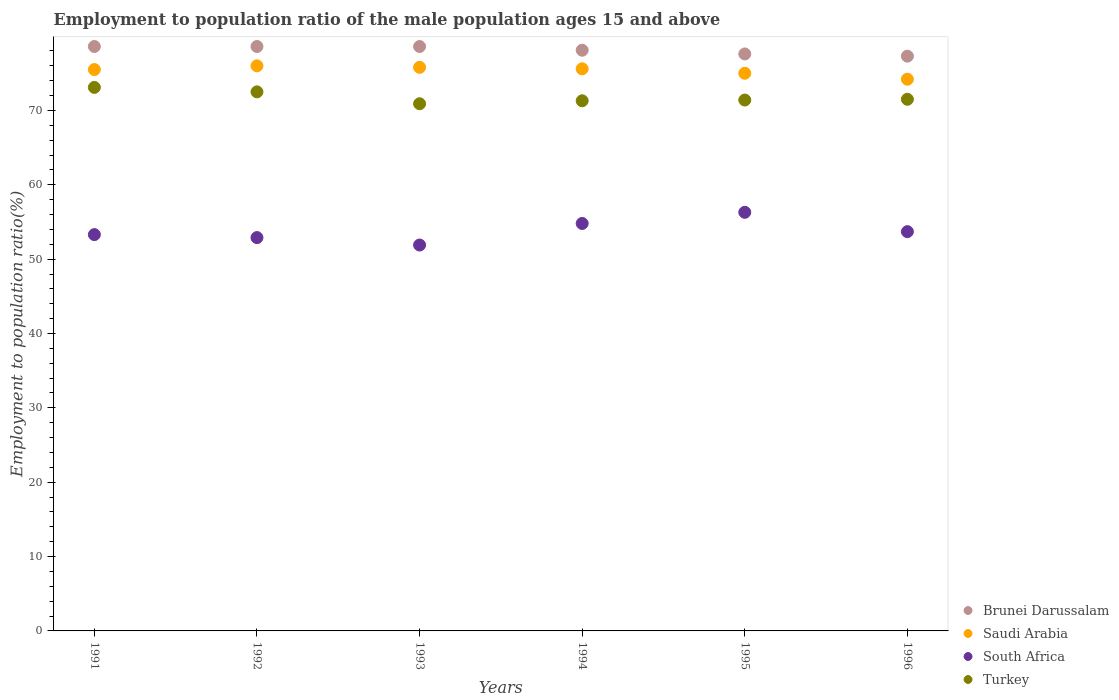Is the number of dotlines equal to the number of legend labels?
Offer a very short reply. Yes. What is the employment to population ratio in South Africa in 1995?
Offer a very short reply. 56.3. Across all years, what is the maximum employment to population ratio in South Africa?
Your answer should be compact. 56.3. Across all years, what is the minimum employment to population ratio in Brunei Darussalam?
Your response must be concise. 77.3. In which year was the employment to population ratio in Brunei Darussalam maximum?
Offer a very short reply. 1991. In which year was the employment to population ratio in South Africa minimum?
Ensure brevity in your answer.  1993. What is the total employment to population ratio in Turkey in the graph?
Give a very brief answer. 430.7. What is the difference between the employment to population ratio in Turkey in 1992 and that in 1994?
Offer a terse response. 1.2. What is the difference between the employment to population ratio in Turkey in 1992 and the employment to population ratio in Brunei Darussalam in 1995?
Provide a short and direct response. -5.1. What is the average employment to population ratio in Saudi Arabia per year?
Provide a short and direct response. 75.35. In the year 1991, what is the difference between the employment to population ratio in Saudi Arabia and employment to population ratio in South Africa?
Ensure brevity in your answer.  22.2. What is the ratio of the employment to population ratio in South Africa in 1991 to that in 1995?
Offer a very short reply. 0.95. Is the employment to population ratio in Turkey in 1992 less than that in 1994?
Your answer should be compact. No. What is the difference between the highest and the second highest employment to population ratio in Turkey?
Your answer should be compact. 0.6. What is the difference between the highest and the lowest employment to population ratio in Saudi Arabia?
Keep it short and to the point. 1.8. In how many years, is the employment to population ratio in South Africa greater than the average employment to population ratio in South Africa taken over all years?
Provide a short and direct response. 2. Is the sum of the employment to population ratio in Turkey in 1992 and 1994 greater than the maximum employment to population ratio in Brunei Darussalam across all years?
Ensure brevity in your answer.  Yes. Does the employment to population ratio in Brunei Darussalam monotonically increase over the years?
Ensure brevity in your answer.  No. Is the employment to population ratio in South Africa strictly less than the employment to population ratio in Saudi Arabia over the years?
Your response must be concise. Yes. How many dotlines are there?
Keep it short and to the point. 4. How many years are there in the graph?
Ensure brevity in your answer.  6. What is the difference between two consecutive major ticks on the Y-axis?
Your answer should be compact. 10. Does the graph contain any zero values?
Give a very brief answer. No. What is the title of the graph?
Keep it short and to the point. Employment to population ratio of the male population ages 15 and above. Does "Trinidad and Tobago" appear as one of the legend labels in the graph?
Provide a succinct answer. No. What is the label or title of the Y-axis?
Offer a terse response. Employment to population ratio(%). What is the Employment to population ratio(%) in Brunei Darussalam in 1991?
Your response must be concise. 78.6. What is the Employment to population ratio(%) of Saudi Arabia in 1991?
Your response must be concise. 75.5. What is the Employment to population ratio(%) in South Africa in 1991?
Keep it short and to the point. 53.3. What is the Employment to population ratio(%) in Turkey in 1991?
Keep it short and to the point. 73.1. What is the Employment to population ratio(%) in Brunei Darussalam in 1992?
Provide a succinct answer. 78.6. What is the Employment to population ratio(%) in South Africa in 1992?
Give a very brief answer. 52.9. What is the Employment to population ratio(%) of Turkey in 1992?
Give a very brief answer. 72.5. What is the Employment to population ratio(%) in Brunei Darussalam in 1993?
Keep it short and to the point. 78.6. What is the Employment to population ratio(%) in Saudi Arabia in 1993?
Keep it short and to the point. 75.8. What is the Employment to population ratio(%) of South Africa in 1993?
Offer a terse response. 51.9. What is the Employment to population ratio(%) of Turkey in 1993?
Make the answer very short. 70.9. What is the Employment to population ratio(%) of Brunei Darussalam in 1994?
Provide a succinct answer. 78.1. What is the Employment to population ratio(%) in Saudi Arabia in 1994?
Offer a very short reply. 75.6. What is the Employment to population ratio(%) in South Africa in 1994?
Give a very brief answer. 54.8. What is the Employment to population ratio(%) of Turkey in 1994?
Your answer should be compact. 71.3. What is the Employment to population ratio(%) of Brunei Darussalam in 1995?
Your response must be concise. 77.6. What is the Employment to population ratio(%) of Saudi Arabia in 1995?
Offer a terse response. 75. What is the Employment to population ratio(%) in South Africa in 1995?
Your response must be concise. 56.3. What is the Employment to population ratio(%) of Turkey in 1995?
Provide a succinct answer. 71.4. What is the Employment to population ratio(%) in Brunei Darussalam in 1996?
Your answer should be very brief. 77.3. What is the Employment to population ratio(%) of Saudi Arabia in 1996?
Offer a terse response. 74.2. What is the Employment to population ratio(%) of South Africa in 1996?
Keep it short and to the point. 53.7. What is the Employment to population ratio(%) in Turkey in 1996?
Give a very brief answer. 71.5. Across all years, what is the maximum Employment to population ratio(%) in Brunei Darussalam?
Provide a succinct answer. 78.6. Across all years, what is the maximum Employment to population ratio(%) in Saudi Arabia?
Ensure brevity in your answer.  76. Across all years, what is the maximum Employment to population ratio(%) in South Africa?
Make the answer very short. 56.3. Across all years, what is the maximum Employment to population ratio(%) of Turkey?
Make the answer very short. 73.1. Across all years, what is the minimum Employment to population ratio(%) in Brunei Darussalam?
Make the answer very short. 77.3. Across all years, what is the minimum Employment to population ratio(%) in Saudi Arabia?
Provide a short and direct response. 74.2. Across all years, what is the minimum Employment to population ratio(%) of South Africa?
Ensure brevity in your answer.  51.9. Across all years, what is the minimum Employment to population ratio(%) of Turkey?
Ensure brevity in your answer.  70.9. What is the total Employment to population ratio(%) of Brunei Darussalam in the graph?
Give a very brief answer. 468.8. What is the total Employment to population ratio(%) of Saudi Arabia in the graph?
Offer a terse response. 452.1. What is the total Employment to population ratio(%) of South Africa in the graph?
Provide a succinct answer. 322.9. What is the total Employment to population ratio(%) of Turkey in the graph?
Make the answer very short. 430.7. What is the difference between the Employment to population ratio(%) in Brunei Darussalam in 1991 and that in 1992?
Provide a succinct answer. 0. What is the difference between the Employment to population ratio(%) in South Africa in 1991 and that in 1992?
Ensure brevity in your answer.  0.4. What is the difference between the Employment to population ratio(%) of Brunei Darussalam in 1991 and that in 1993?
Your response must be concise. 0. What is the difference between the Employment to population ratio(%) in Saudi Arabia in 1991 and that in 1993?
Your answer should be very brief. -0.3. What is the difference between the Employment to population ratio(%) of Turkey in 1991 and that in 1994?
Your response must be concise. 1.8. What is the difference between the Employment to population ratio(%) of Brunei Darussalam in 1991 and that in 1995?
Provide a short and direct response. 1. What is the difference between the Employment to population ratio(%) in South Africa in 1991 and that in 1995?
Offer a very short reply. -3. What is the difference between the Employment to population ratio(%) in Turkey in 1991 and that in 1995?
Give a very brief answer. 1.7. What is the difference between the Employment to population ratio(%) in Brunei Darussalam in 1991 and that in 1996?
Make the answer very short. 1.3. What is the difference between the Employment to population ratio(%) in Saudi Arabia in 1991 and that in 1996?
Offer a very short reply. 1.3. What is the difference between the Employment to population ratio(%) of Turkey in 1991 and that in 1996?
Offer a very short reply. 1.6. What is the difference between the Employment to population ratio(%) in Saudi Arabia in 1992 and that in 1993?
Your answer should be very brief. 0.2. What is the difference between the Employment to population ratio(%) of Turkey in 1992 and that in 1993?
Provide a short and direct response. 1.6. What is the difference between the Employment to population ratio(%) in Saudi Arabia in 1992 and that in 1994?
Give a very brief answer. 0.4. What is the difference between the Employment to population ratio(%) in South Africa in 1992 and that in 1994?
Your answer should be very brief. -1.9. What is the difference between the Employment to population ratio(%) in South Africa in 1992 and that in 1995?
Keep it short and to the point. -3.4. What is the difference between the Employment to population ratio(%) of Turkey in 1992 and that in 1995?
Keep it short and to the point. 1.1. What is the difference between the Employment to population ratio(%) of Brunei Darussalam in 1992 and that in 1996?
Provide a succinct answer. 1.3. What is the difference between the Employment to population ratio(%) of Saudi Arabia in 1992 and that in 1996?
Make the answer very short. 1.8. What is the difference between the Employment to population ratio(%) of South Africa in 1992 and that in 1996?
Your answer should be compact. -0.8. What is the difference between the Employment to population ratio(%) in Turkey in 1992 and that in 1996?
Make the answer very short. 1. What is the difference between the Employment to population ratio(%) in Saudi Arabia in 1993 and that in 1994?
Offer a terse response. 0.2. What is the difference between the Employment to population ratio(%) in Turkey in 1993 and that in 1994?
Ensure brevity in your answer.  -0.4. What is the difference between the Employment to population ratio(%) in Brunei Darussalam in 1993 and that in 1995?
Your response must be concise. 1. What is the difference between the Employment to population ratio(%) of Turkey in 1993 and that in 1995?
Provide a short and direct response. -0.5. What is the difference between the Employment to population ratio(%) in Saudi Arabia in 1993 and that in 1996?
Provide a short and direct response. 1.6. What is the difference between the Employment to population ratio(%) in South Africa in 1993 and that in 1996?
Make the answer very short. -1.8. What is the difference between the Employment to population ratio(%) of Saudi Arabia in 1994 and that in 1995?
Make the answer very short. 0.6. What is the difference between the Employment to population ratio(%) of South Africa in 1994 and that in 1995?
Keep it short and to the point. -1.5. What is the difference between the Employment to population ratio(%) of Brunei Darussalam in 1994 and that in 1996?
Your answer should be compact. 0.8. What is the difference between the Employment to population ratio(%) in Saudi Arabia in 1994 and that in 1996?
Make the answer very short. 1.4. What is the difference between the Employment to population ratio(%) of South Africa in 1994 and that in 1996?
Make the answer very short. 1.1. What is the difference between the Employment to population ratio(%) in Saudi Arabia in 1995 and that in 1996?
Make the answer very short. 0.8. What is the difference between the Employment to population ratio(%) in South Africa in 1995 and that in 1996?
Provide a short and direct response. 2.6. What is the difference between the Employment to population ratio(%) in Turkey in 1995 and that in 1996?
Give a very brief answer. -0.1. What is the difference between the Employment to population ratio(%) of Brunei Darussalam in 1991 and the Employment to population ratio(%) of South Africa in 1992?
Give a very brief answer. 25.7. What is the difference between the Employment to population ratio(%) of Brunei Darussalam in 1991 and the Employment to population ratio(%) of Turkey in 1992?
Your answer should be very brief. 6.1. What is the difference between the Employment to population ratio(%) in Saudi Arabia in 1991 and the Employment to population ratio(%) in South Africa in 1992?
Offer a terse response. 22.6. What is the difference between the Employment to population ratio(%) in South Africa in 1991 and the Employment to population ratio(%) in Turkey in 1992?
Offer a very short reply. -19.2. What is the difference between the Employment to population ratio(%) in Brunei Darussalam in 1991 and the Employment to population ratio(%) in South Africa in 1993?
Ensure brevity in your answer.  26.7. What is the difference between the Employment to population ratio(%) of Saudi Arabia in 1991 and the Employment to population ratio(%) of South Africa in 1993?
Offer a terse response. 23.6. What is the difference between the Employment to population ratio(%) of South Africa in 1991 and the Employment to population ratio(%) of Turkey in 1993?
Your answer should be compact. -17.6. What is the difference between the Employment to population ratio(%) of Brunei Darussalam in 1991 and the Employment to population ratio(%) of South Africa in 1994?
Make the answer very short. 23.8. What is the difference between the Employment to population ratio(%) of Brunei Darussalam in 1991 and the Employment to population ratio(%) of Turkey in 1994?
Make the answer very short. 7.3. What is the difference between the Employment to population ratio(%) in Saudi Arabia in 1991 and the Employment to population ratio(%) in South Africa in 1994?
Provide a succinct answer. 20.7. What is the difference between the Employment to population ratio(%) in South Africa in 1991 and the Employment to population ratio(%) in Turkey in 1994?
Your answer should be very brief. -18. What is the difference between the Employment to population ratio(%) in Brunei Darussalam in 1991 and the Employment to population ratio(%) in Saudi Arabia in 1995?
Offer a very short reply. 3.6. What is the difference between the Employment to population ratio(%) in Brunei Darussalam in 1991 and the Employment to population ratio(%) in South Africa in 1995?
Your response must be concise. 22.3. What is the difference between the Employment to population ratio(%) in South Africa in 1991 and the Employment to population ratio(%) in Turkey in 1995?
Ensure brevity in your answer.  -18.1. What is the difference between the Employment to population ratio(%) of Brunei Darussalam in 1991 and the Employment to population ratio(%) of South Africa in 1996?
Give a very brief answer. 24.9. What is the difference between the Employment to population ratio(%) of Brunei Darussalam in 1991 and the Employment to population ratio(%) of Turkey in 1996?
Your answer should be compact. 7.1. What is the difference between the Employment to population ratio(%) in Saudi Arabia in 1991 and the Employment to population ratio(%) in South Africa in 1996?
Your response must be concise. 21.8. What is the difference between the Employment to population ratio(%) in Saudi Arabia in 1991 and the Employment to population ratio(%) in Turkey in 1996?
Provide a short and direct response. 4. What is the difference between the Employment to population ratio(%) of South Africa in 1991 and the Employment to population ratio(%) of Turkey in 1996?
Offer a terse response. -18.2. What is the difference between the Employment to population ratio(%) in Brunei Darussalam in 1992 and the Employment to population ratio(%) in South Africa in 1993?
Provide a short and direct response. 26.7. What is the difference between the Employment to population ratio(%) of Brunei Darussalam in 1992 and the Employment to population ratio(%) of Turkey in 1993?
Ensure brevity in your answer.  7.7. What is the difference between the Employment to population ratio(%) in Saudi Arabia in 1992 and the Employment to population ratio(%) in South Africa in 1993?
Ensure brevity in your answer.  24.1. What is the difference between the Employment to population ratio(%) in Saudi Arabia in 1992 and the Employment to population ratio(%) in Turkey in 1993?
Make the answer very short. 5.1. What is the difference between the Employment to population ratio(%) of South Africa in 1992 and the Employment to population ratio(%) of Turkey in 1993?
Provide a succinct answer. -18. What is the difference between the Employment to population ratio(%) in Brunei Darussalam in 1992 and the Employment to population ratio(%) in South Africa in 1994?
Your answer should be very brief. 23.8. What is the difference between the Employment to population ratio(%) of Brunei Darussalam in 1992 and the Employment to population ratio(%) of Turkey in 1994?
Offer a terse response. 7.3. What is the difference between the Employment to population ratio(%) of Saudi Arabia in 1992 and the Employment to population ratio(%) of South Africa in 1994?
Keep it short and to the point. 21.2. What is the difference between the Employment to population ratio(%) of Saudi Arabia in 1992 and the Employment to population ratio(%) of Turkey in 1994?
Provide a short and direct response. 4.7. What is the difference between the Employment to population ratio(%) in South Africa in 1992 and the Employment to population ratio(%) in Turkey in 1994?
Offer a terse response. -18.4. What is the difference between the Employment to population ratio(%) in Brunei Darussalam in 1992 and the Employment to population ratio(%) in Saudi Arabia in 1995?
Give a very brief answer. 3.6. What is the difference between the Employment to population ratio(%) of Brunei Darussalam in 1992 and the Employment to population ratio(%) of South Africa in 1995?
Offer a very short reply. 22.3. What is the difference between the Employment to population ratio(%) of Brunei Darussalam in 1992 and the Employment to population ratio(%) of Turkey in 1995?
Your response must be concise. 7.2. What is the difference between the Employment to population ratio(%) of South Africa in 1992 and the Employment to population ratio(%) of Turkey in 1995?
Offer a very short reply. -18.5. What is the difference between the Employment to population ratio(%) of Brunei Darussalam in 1992 and the Employment to population ratio(%) of Saudi Arabia in 1996?
Offer a very short reply. 4.4. What is the difference between the Employment to population ratio(%) in Brunei Darussalam in 1992 and the Employment to population ratio(%) in South Africa in 1996?
Make the answer very short. 24.9. What is the difference between the Employment to population ratio(%) of Saudi Arabia in 1992 and the Employment to population ratio(%) of South Africa in 1996?
Provide a short and direct response. 22.3. What is the difference between the Employment to population ratio(%) in Saudi Arabia in 1992 and the Employment to population ratio(%) in Turkey in 1996?
Offer a terse response. 4.5. What is the difference between the Employment to population ratio(%) in South Africa in 1992 and the Employment to population ratio(%) in Turkey in 1996?
Keep it short and to the point. -18.6. What is the difference between the Employment to population ratio(%) of Brunei Darussalam in 1993 and the Employment to population ratio(%) of South Africa in 1994?
Provide a succinct answer. 23.8. What is the difference between the Employment to population ratio(%) in Brunei Darussalam in 1993 and the Employment to population ratio(%) in Turkey in 1994?
Your response must be concise. 7.3. What is the difference between the Employment to population ratio(%) of Saudi Arabia in 1993 and the Employment to population ratio(%) of South Africa in 1994?
Your response must be concise. 21. What is the difference between the Employment to population ratio(%) in Saudi Arabia in 1993 and the Employment to population ratio(%) in Turkey in 1994?
Keep it short and to the point. 4.5. What is the difference between the Employment to population ratio(%) in South Africa in 1993 and the Employment to population ratio(%) in Turkey in 1994?
Make the answer very short. -19.4. What is the difference between the Employment to population ratio(%) of Brunei Darussalam in 1993 and the Employment to population ratio(%) of South Africa in 1995?
Provide a succinct answer. 22.3. What is the difference between the Employment to population ratio(%) in Brunei Darussalam in 1993 and the Employment to population ratio(%) in Turkey in 1995?
Provide a short and direct response. 7.2. What is the difference between the Employment to population ratio(%) in Saudi Arabia in 1993 and the Employment to population ratio(%) in South Africa in 1995?
Ensure brevity in your answer.  19.5. What is the difference between the Employment to population ratio(%) of South Africa in 1993 and the Employment to population ratio(%) of Turkey in 1995?
Provide a succinct answer. -19.5. What is the difference between the Employment to population ratio(%) of Brunei Darussalam in 1993 and the Employment to population ratio(%) of South Africa in 1996?
Offer a very short reply. 24.9. What is the difference between the Employment to population ratio(%) of Saudi Arabia in 1993 and the Employment to population ratio(%) of South Africa in 1996?
Provide a short and direct response. 22.1. What is the difference between the Employment to population ratio(%) of Saudi Arabia in 1993 and the Employment to population ratio(%) of Turkey in 1996?
Offer a very short reply. 4.3. What is the difference between the Employment to population ratio(%) of South Africa in 1993 and the Employment to population ratio(%) of Turkey in 1996?
Provide a short and direct response. -19.6. What is the difference between the Employment to population ratio(%) in Brunei Darussalam in 1994 and the Employment to population ratio(%) in South Africa in 1995?
Provide a succinct answer. 21.8. What is the difference between the Employment to population ratio(%) in Brunei Darussalam in 1994 and the Employment to population ratio(%) in Turkey in 1995?
Give a very brief answer. 6.7. What is the difference between the Employment to population ratio(%) of Saudi Arabia in 1994 and the Employment to population ratio(%) of South Africa in 1995?
Offer a very short reply. 19.3. What is the difference between the Employment to population ratio(%) of Saudi Arabia in 1994 and the Employment to population ratio(%) of Turkey in 1995?
Keep it short and to the point. 4.2. What is the difference between the Employment to population ratio(%) of South Africa in 1994 and the Employment to population ratio(%) of Turkey in 1995?
Give a very brief answer. -16.6. What is the difference between the Employment to population ratio(%) in Brunei Darussalam in 1994 and the Employment to population ratio(%) in Saudi Arabia in 1996?
Your answer should be very brief. 3.9. What is the difference between the Employment to population ratio(%) in Brunei Darussalam in 1994 and the Employment to population ratio(%) in South Africa in 1996?
Your answer should be compact. 24.4. What is the difference between the Employment to population ratio(%) in Saudi Arabia in 1994 and the Employment to population ratio(%) in South Africa in 1996?
Ensure brevity in your answer.  21.9. What is the difference between the Employment to population ratio(%) in Saudi Arabia in 1994 and the Employment to population ratio(%) in Turkey in 1996?
Make the answer very short. 4.1. What is the difference between the Employment to population ratio(%) of South Africa in 1994 and the Employment to population ratio(%) of Turkey in 1996?
Offer a very short reply. -16.7. What is the difference between the Employment to population ratio(%) in Brunei Darussalam in 1995 and the Employment to population ratio(%) in South Africa in 1996?
Ensure brevity in your answer.  23.9. What is the difference between the Employment to population ratio(%) of Saudi Arabia in 1995 and the Employment to population ratio(%) of South Africa in 1996?
Your response must be concise. 21.3. What is the difference between the Employment to population ratio(%) in South Africa in 1995 and the Employment to population ratio(%) in Turkey in 1996?
Your answer should be very brief. -15.2. What is the average Employment to population ratio(%) of Brunei Darussalam per year?
Your response must be concise. 78.13. What is the average Employment to population ratio(%) of Saudi Arabia per year?
Your response must be concise. 75.35. What is the average Employment to population ratio(%) of South Africa per year?
Provide a succinct answer. 53.82. What is the average Employment to population ratio(%) in Turkey per year?
Give a very brief answer. 71.78. In the year 1991, what is the difference between the Employment to population ratio(%) in Brunei Darussalam and Employment to population ratio(%) in South Africa?
Your response must be concise. 25.3. In the year 1991, what is the difference between the Employment to population ratio(%) of Brunei Darussalam and Employment to population ratio(%) of Turkey?
Your answer should be compact. 5.5. In the year 1991, what is the difference between the Employment to population ratio(%) of Saudi Arabia and Employment to population ratio(%) of South Africa?
Offer a very short reply. 22.2. In the year 1991, what is the difference between the Employment to population ratio(%) in Saudi Arabia and Employment to population ratio(%) in Turkey?
Provide a succinct answer. 2.4. In the year 1991, what is the difference between the Employment to population ratio(%) of South Africa and Employment to population ratio(%) of Turkey?
Offer a terse response. -19.8. In the year 1992, what is the difference between the Employment to population ratio(%) in Brunei Darussalam and Employment to population ratio(%) in Saudi Arabia?
Offer a very short reply. 2.6. In the year 1992, what is the difference between the Employment to population ratio(%) of Brunei Darussalam and Employment to population ratio(%) of South Africa?
Offer a terse response. 25.7. In the year 1992, what is the difference between the Employment to population ratio(%) of Saudi Arabia and Employment to population ratio(%) of South Africa?
Your answer should be very brief. 23.1. In the year 1992, what is the difference between the Employment to population ratio(%) of Saudi Arabia and Employment to population ratio(%) of Turkey?
Your response must be concise. 3.5. In the year 1992, what is the difference between the Employment to population ratio(%) of South Africa and Employment to population ratio(%) of Turkey?
Your response must be concise. -19.6. In the year 1993, what is the difference between the Employment to population ratio(%) of Brunei Darussalam and Employment to population ratio(%) of Saudi Arabia?
Give a very brief answer. 2.8. In the year 1993, what is the difference between the Employment to population ratio(%) of Brunei Darussalam and Employment to population ratio(%) of South Africa?
Offer a very short reply. 26.7. In the year 1993, what is the difference between the Employment to population ratio(%) in Brunei Darussalam and Employment to population ratio(%) in Turkey?
Ensure brevity in your answer.  7.7. In the year 1993, what is the difference between the Employment to population ratio(%) in Saudi Arabia and Employment to population ratio(%) in South Africa?
Provide a succinct answer. 23.9. In the year 1993, what is the difference between the Employment to population ratio(%) of Saudi Arabia and Employment to population ratio(%) of Turkey?
Your answer should be compact. 4.9. In the year 1993, what is the difference between the Employment to population ratio(%) of South Africa and Employment to population ratio(%) of Turkey?
Your answer should be compact. -19. In the year 1994, what is the difference between the Employment to population ratio(%) in Brunei Darussalam and Employment to population ratio(%) in South Africa?
Provide a short and direct response. 23.3. In the year 1994, what is the difference between the Employment to population ratio(%) in Brunei Darussalam and Employment to population ratio(%) in Turkey?
Give a very brief answer. 6.8. In the year 1994, what is the difference between the Employment to population ratio(%) in Saudi Arabia and Employment to population ratio(%) in South Africa?
Your answer should be compact. 20.8. In the year 1994, what is the difference between the Employment to population ratio(%) in South Africa and Employment to population ratio(%) in Turkey?
Make the answer very short. -16.5. In the year 1995, what is the difference between the Employment to population ratio(%) of Brunei Darussalam and Employment to population ratio(%) of South Africa?
Ensure brevity in your answer.  21.3. In the year 1995, what is the difference between the Employment to population ratio(%) in Saudi Arabia and Employment to population ratio(%) in South Africa?
Offer a terse response. 18.7. In the year 1995, what is the difference between the Employment to population ratio(%) of Saudi Arabia and Employment to population ratio(%) of Turkey?
Offer a very short reply. 3.6. In the year 1995, what is the difference between the Employment to population ratio(%) of South Africa and Employment to population ratio(%) of Turkey?
Your response must be concise. -15.1. In the year 1996, what is the difference between the Employment to population ratio(%) of Brunei Darussalam and Employment to population ratio(%) of Saudi Arabia?
Offer a very short reply. 3.1. In the year 1996, what is the difference between the Employment to population ratio(%) in Brunei Darussalam and Employment to population ratio(%) in South Africa?
Offer a terse response. 23.6. In the year 1996, what is the difference between the Employment to population ratio(%) in South Africa and Employment to population ratio(%) in Turkey?
Ensure brevity in your answer.  -17.8. What is the ratio of the Employment to population ratio(%) in Saudi Arabia in 1991 to that in 1992?
Offer a very short reply. 0.99. What is the ratio of the Employment to population ratio(%) of South Africa in 1991 to that in 1992?
Your response must be concise. 1.01. What is the ratio of the Employment to population ratio(%) in Turkey in 1991 to that in 1992?
Keep it short and to the point. 1.01. What is the ratio of the Employment to population ratio(%) of Turkey in 1991 to that in 1993?
Ensure brevity in your answer.  1.03. What is the ratio of the Employment to population ratio(%) in Brunei Darussalam in 1991 to that in 1994?
Make the answer very short. 1.01. What is the ratio of the Employment to population ratio(%) of Saudi Arabia in 1991 to that in 1994?
Offer a terse response. 1. What is the ratio of the Employment to population ratio(%) in South Africa in 1991 to that in 1994?
Give a very brief answer. 0.97. What is the ratio of the Employment to population ratio(%) in Turkey in 1991 to that in 1994?
Ensure brevity in your answer.  1.03. What is the ratio of the Employment to population ratio(%) in Brunei Darussalam in 1991 to that in 1995?
Provide a succinct answer. 1.01. What is the ratio of the Employment to population ratio(%) in Saudi Arabia in 1991 to that in 1995?
Offer a very short reply. 1.01. What is the ratio of the Employment to population ratio(%) in South Africa in 1991 to that in 1995?
Ensure brevity in your answer.  0.95. What is the ratio of the Employment to population ratio(%) in Turkey in 1991 to that in 1995?
Your response must be concise. 1.02. What is the ratio of the Employment to population ratio(%) in Brunei Darussalam in 1991 to that in 1996?
Offer a terse response. 1.02. What is the ratio of the Employment to population ratio(%) in Saudi Arabia in 1991 to that in 1996?
Provide a succinct answer. 1.02. What is the ratio of the Employment to population ratio(%) in Turkey in 1991 to that in 1996?
Your answer should be very brief. 1.02. What is the ratio of the Employment to population ratio(%) in Saudi Arabia in 1992 to that in 1993?
Ensure brevity in your answer.  1. What is the ratio of the Employment to population ratio(%) of South Africa in 1992 to that in 1993?
Keep it short and to the point. 1.02. What is the ratio of the Employment to population ratio(%) of Turkey in 1992 to that in 1993?
Make the answer very short. 1.02. What is the ratio of the Employment to population ratio(%) in Brunei Darussalam in 1992 to that in 1994?
Offer a terse response. 1.01. What is the ratio of the Employment to population ratio(%) in South Africa in 1992 to that in 1994?
Give a very brief answer. 0.97. What is the ratio of the Employment to population ratio(%) in Turkey in 1992 to that in 1994?
Your answer should be compact. 1.02. What is the ratio of the Employment to population ratio(%) in Brunei Darussalam in 1992 to that in 1995?
Ensure brevity in your answer.  1.01. What is the ratio of the Employment to population ratio(%) of Saudi Arabia in 1992 to that in 1995?
Your response must be concise. 1.01. What is the ratio of the Employment to population ratio(%) of South Africa in 1992 to that in 1995?
Offer a very short reply. 0.94. What is the ratio of the Employment to population ratio(%) of Turkey in 1992 to that in 1995?
Your answer should be compact. 1.02. What is the ratio of the Employment to population ratio(%) in Brunei Darussalam in 1992 to that in 1996?
Make the answer very short. 1.02. What is the ratio of the Employment to population ratio(%) of Saudi Arabia in 1992 to that in 1996?
Your response must be concise. 1.02. What is the ratio of the Employment to population ratio(%) of South Africa in 1992 to that in 1996?
Make the answer very short. 0.99. What is the ratio of the Employment to population ratio(%) of Turkey in 1992 to that in 1996?
Make the answer very short. 1.01. What is the ratio of the Employment to population ratio(%) in Brunei Darussalam in 1993 to that in 1994?
Provide a short and direct response. 1.01. What is the ratio of the Employment to population ratio(%) of South Africa in 1993 to that in 1994?
Your answer should be compact. 0.95. What is the ratio of the Employment to population ratio(%) of Brunei Darussalam in 1993 to that in 1995?
Your response must be concise. 1.01. What is the ratio of the Employment to population ratio(%) in Saudi Arabia in 1993 to that in 1995?
Keep it short and to the point. 1.01. What is the ratio of the Employment to population ratio(%) in South Africa in 1993 to that in 1995?
Give a very brief answer. 0.92. What is the ratio of the Employment to population ratio(%) in Brunei Darussalam in 1993 to that in 1996?
Ensure brevity in your answer.  1.02. What is the ratio of the Employment to population ratio(%) of Saudi Arabia in 1993 to that in 1996?
Your response must be concise. 1.02. What is the ratio of the Employment to population ratio(%) of South Africa in 1993 to that in 1996?
Your response must be concise. 0.97. What is the ratio of the Employment to population ratio(%) of Brunei Darussalam in 1994 to that in 1995?
Provide a short and direct response. 1.01. What is the ratio of the Employment to population ratio(%) in Saudi Arabia in 1994 to that in 1995?
Your response must be concise. 1.01. What is the ratio of the Employment to population ratio(%) in South Africa in 1994 to that in 1995?
Offer a terse response. 0.97. What is the ratio of the Employment to population ratio(%) of Brunei Darussalam in 1994 to that in 1996?
Keep it short and to the point. 1.01. What is the ratio of the Employment to population ratio(%) of Saudi Arabia in 1994 to that in 1996?
Offer a terse response. 1.02. What is the ratio of the Employment to population ratio(%) in South Africa in 1994 to that in 1996?
Ensure brevity in your answer.  1.02. What is the ratio of the Employment to population ratio(%) of Turkey in 1994 to that in 1996?
Keep it short and to the point. 1. What is the ratio of the Employment to population ratio(%) of Saudi Arabia in 1995 to that in 1996?
Make the answer very short. 1.01. What is the ratio of the Employment to population ratio(%) of South Africa in 1995 to that in 1996?
Your response must be concise. 1.05. What is the ratio of the Employment to population ratio(%) of Turkey in 1995 to that in 1996?
Make the answer very short. 1. What is the difference between the highest and the second highest Employment to population ratio(%) of South Africa?
Your answer should be very brief. 1.5. What is the difference between the highest and the second highest Employment to population ratio(%) of Turkey?
Your answer should be compact. 0.6. What is the difference between the highest and the lowest Employment to population ratio(%) in Turkey?
Offer a very short reply. 2.2. 